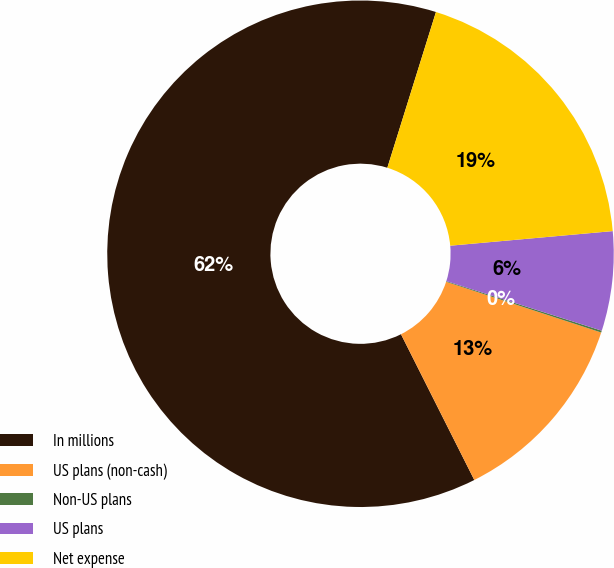Convert chart to OTSL. <chart><loc_0><loc_0><loc_500><loc_500><pie_chart><fcel>In millions<fcel>US plans (non-cash)<fcel>Non-US plans<fcel>US plans<fcel>Net expense<nl><fcel>62.24%<fcel>12.55%<fcel>0.12%<fcel>6.34%<fcel>18.76%<nl></chart> 